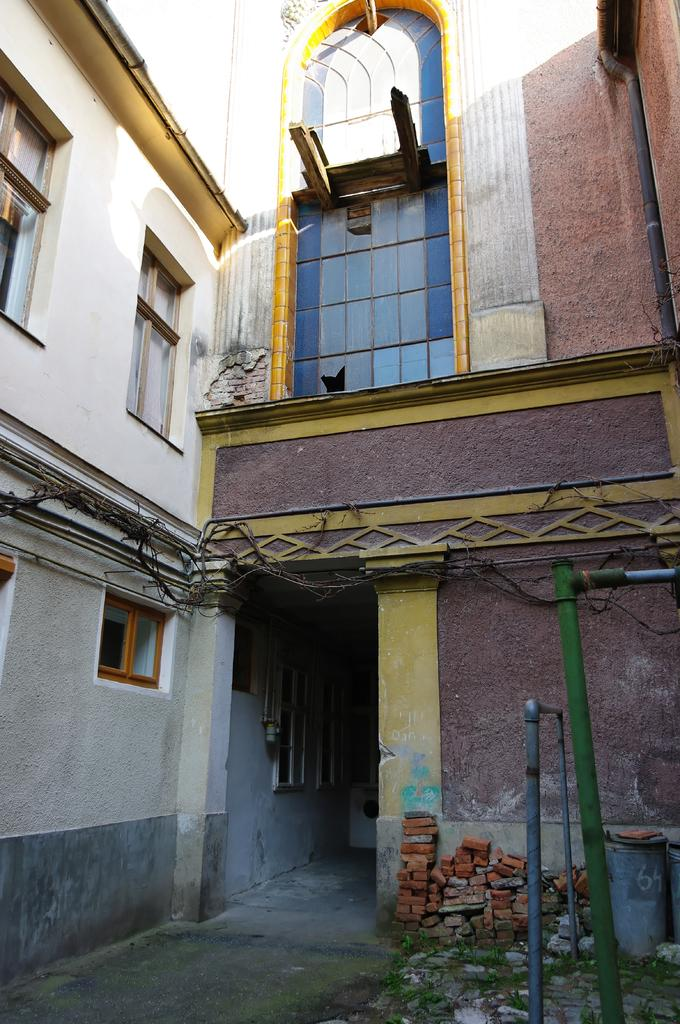What type of structure is present in the image? There is a building in the image. What feature can be seen on the building? The building has windows. What else can be seen in the image besides the building? There are pipes and cables in the image. How many flowers can be seen growing on the building in the image? There are no flowers present on the building in the image. 